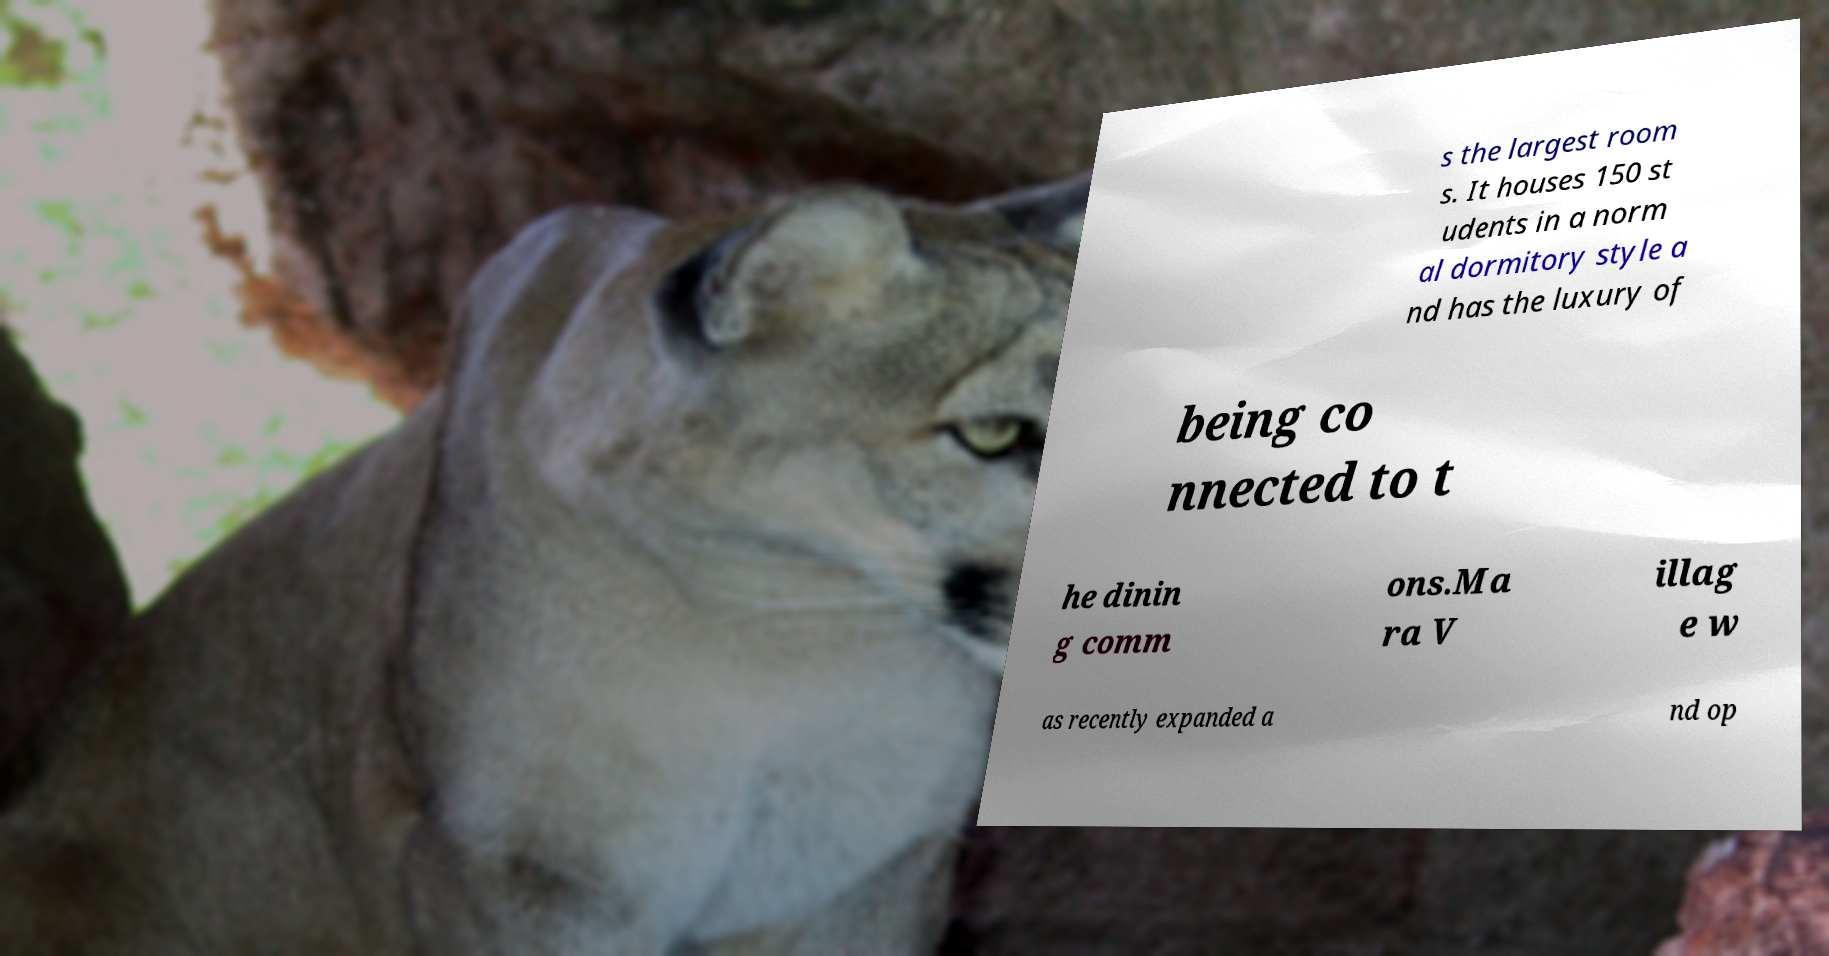Please identify and transcribe the text found in this image. s the largest room s. It houses 150 st udents in a norm al dormitory style a nd has the luxury of being co nnected to t he dinin g comm ons.Ma ra V illag e w as recently expanded a nd op 